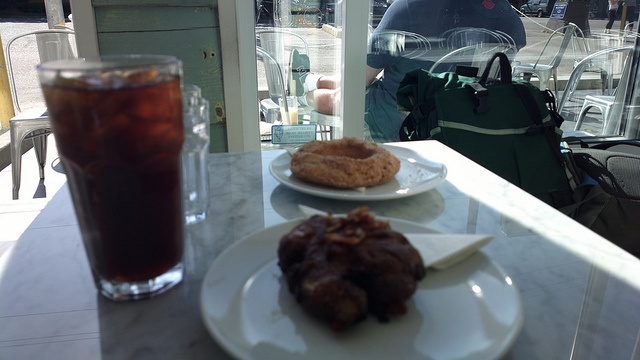Describe the objects in this image and their specific colors. I can see cup in black, gray, maroon, and darkgray tones, dining table in black, darkgray, and gray tones, dining table in black, gray, white, and darkgray tones, suitcase in black, gray, and teal tones, and people in black, navy, blue, and gray tones in this image. 